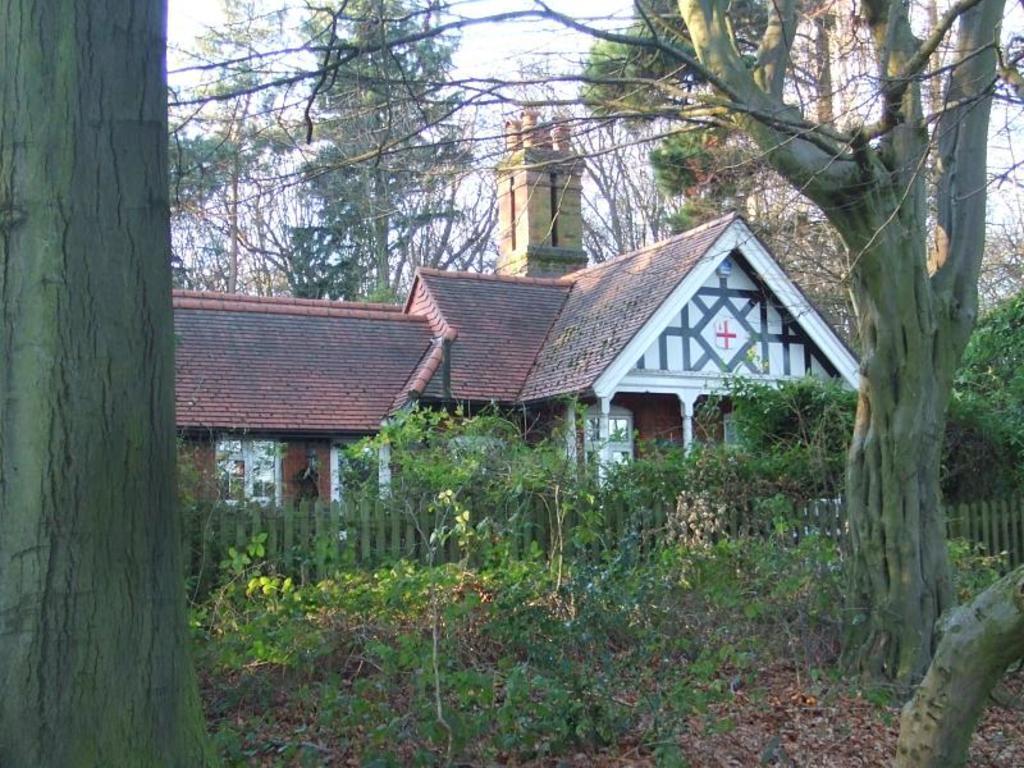In one or two sentences, can you explain what this image depicts? In this image there are trees, house, plants, railing, sky and objects.   